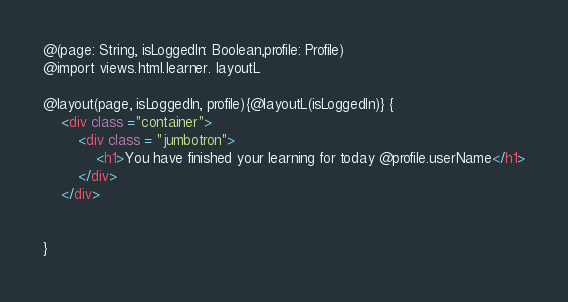Convert code to text. <code><loc_0><loc_0><loc_500><loc_500><_HTML_>@(page: String, isLoggedIn: Boolean,profile: Profile)
@import views.html.learner. layoutL

@layout(page, isLoggedIn, profile){@layoutL(isLoggedIn)} {
    <div class ="container">
        <div class = "jumbotron">
            <h1>You have finished your learning for today @profile.userName</h1>
        </div>
    </div>


}</code> 